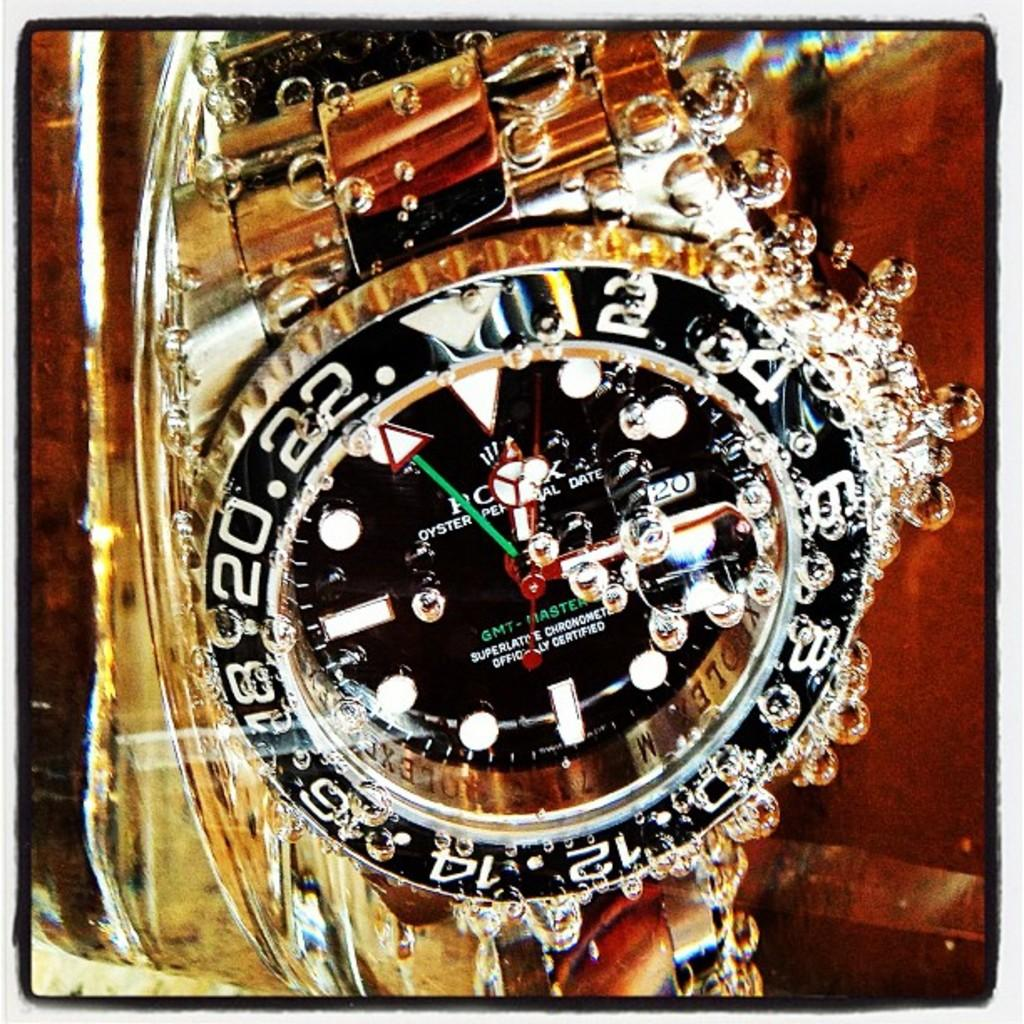<image>
Describe the image concisely. A gold wristwatch submerged in water and it says it is officially certified. 